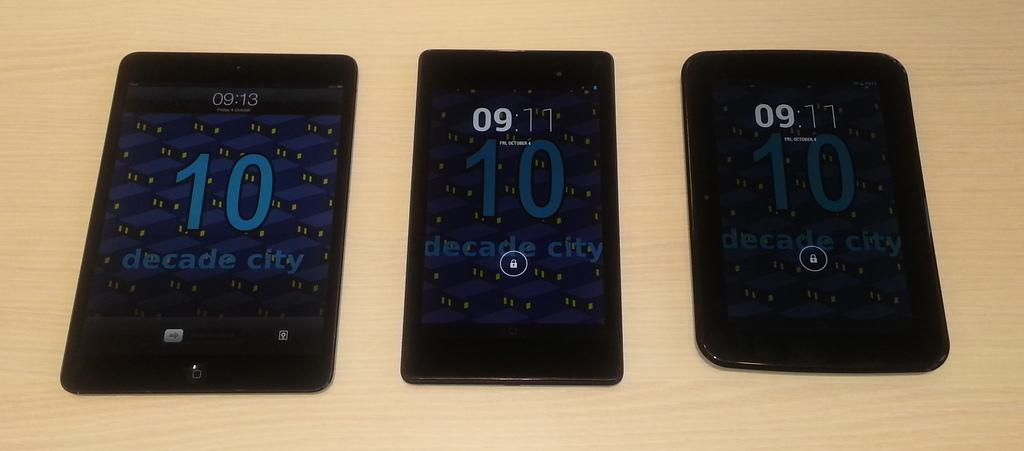<image>
Summarize the visual content of the image. Three electronic hand held devices displaying similar screens with the words "decade city" in different sizes laying next to each other on a table. 